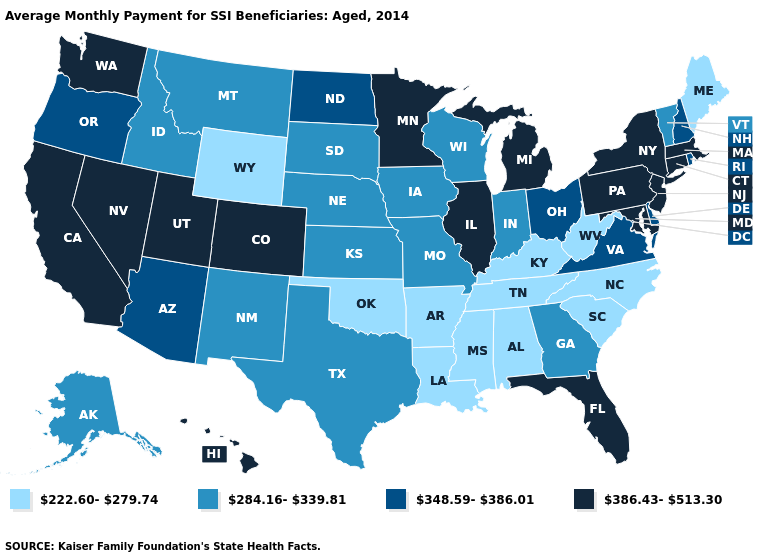Does the first symbol in the legend represent the smallest category?
Concise answer only. Yes. Name the states that have a value in the range 284.16-339.81?
Give a very brief answer. Alaska, Georgia, Idaho, Indiana, Iowa, Kansas, Missouri, Montana, Nebraska, New Mexico, South Dakota, Texas, Vermont, Wisconsin. Which states have the lowest value in the South?
Answer briefly. Alabama, Arkansas, Kentucky, Louisiana, Mississippi, North Carolina, Oklahoma, South Carolina, Tennessee, West Virginia. What is the value of Oklahoma?
Be succinct. 222.60-279.74. What is the highest value in the USA?
Write a very short answer. 386.43-513.30. What is the lowest value in states that border Mississippi?
Quick response, please. 222.60-279.74. Name the states that have a value in the range 348.59-386.01?
Concise answer only. Arizona, Delaware, New Hampshire, North Dakota, Ohio, Oregon, Rhode Island, Virginia. Name the states that have a value in the range 284.16-339.81?
Quick response, please. Alaska, Georgia, Idaho, Indiana, Iowa, Kansas, Missouri, Montana, Nebraska, New Mexico, South Dakota, Texas, Vermont, Wisconsin. What is the value of Louisiana?
Give a very brief answer. 222.60-279.74. What is the value of Nevada?
Concise answer only. 386.43-513.30. What is the highest value in the West ?
Keep it brief. 386.43-513.30. Which states have the highest value in the USA?
Give a very brief answer. California, Colorado, Connecticut, Florida, Hawaii, Illinois, Maryland, Massachusetts, Michigan, Minnesota, Nevada, New Jersey, New York, Pennsylvania, Utah, Washington. What is the value of Montana?
Concise answer only. 284.16-339.81. Does West Virginia have the lowest value in the USA?
Be succinct. Yes. Among the states that border New Mexico , does Arizona have the lowest value?
Give a very brief answer. No. 